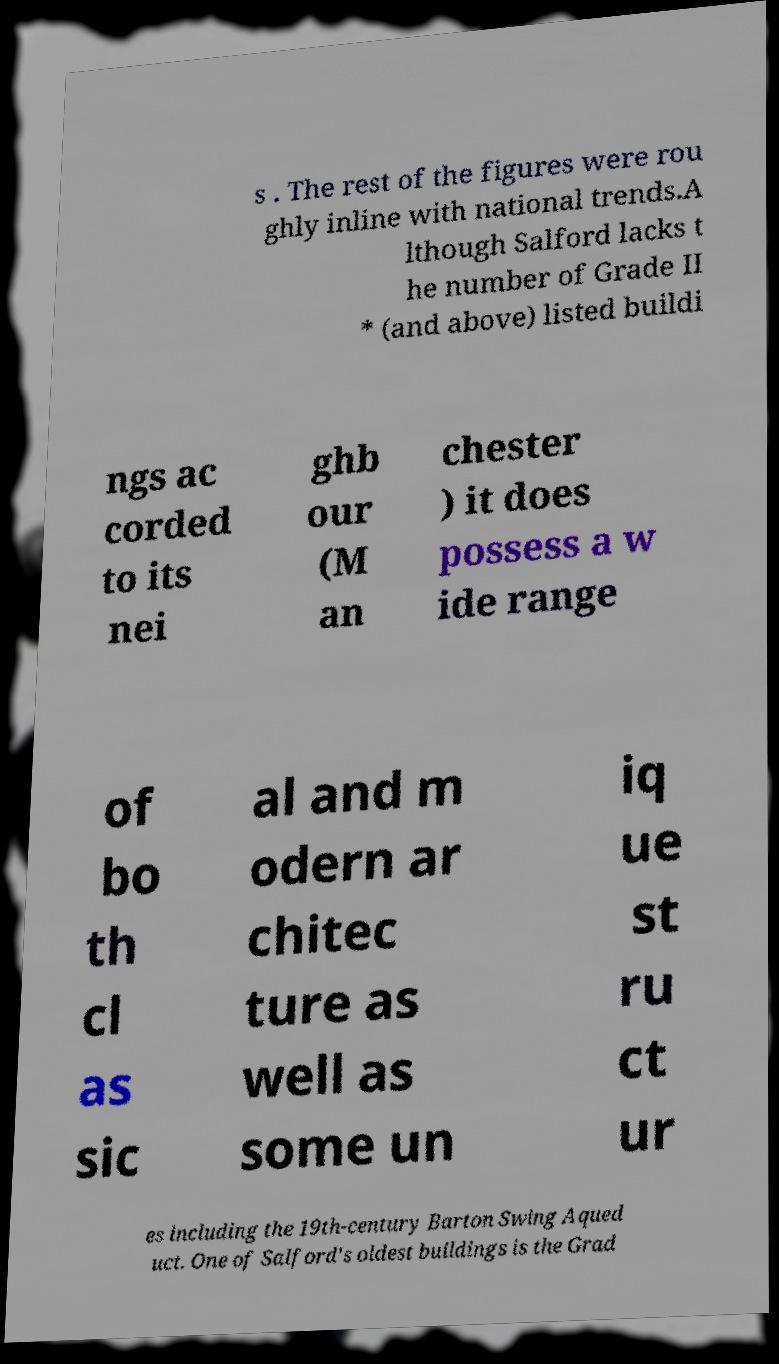What messages or text are displayed in this image? I need them in a readable, typed format. s . The rest of the figures were rou ghly inline with national trends.A lthough Salford lacks t he number of Grade II * (and above) listed buildi ngs ac corded to its nei ghb our (M an chester ) it does possess a w ide range of bo th cl as sic al and m odern ar chitec ture as well as some un iq ue st ru ct ur es including the 19th-century Barton Swing Aqued uct. One of Salford's oldest buildings is the Grad 